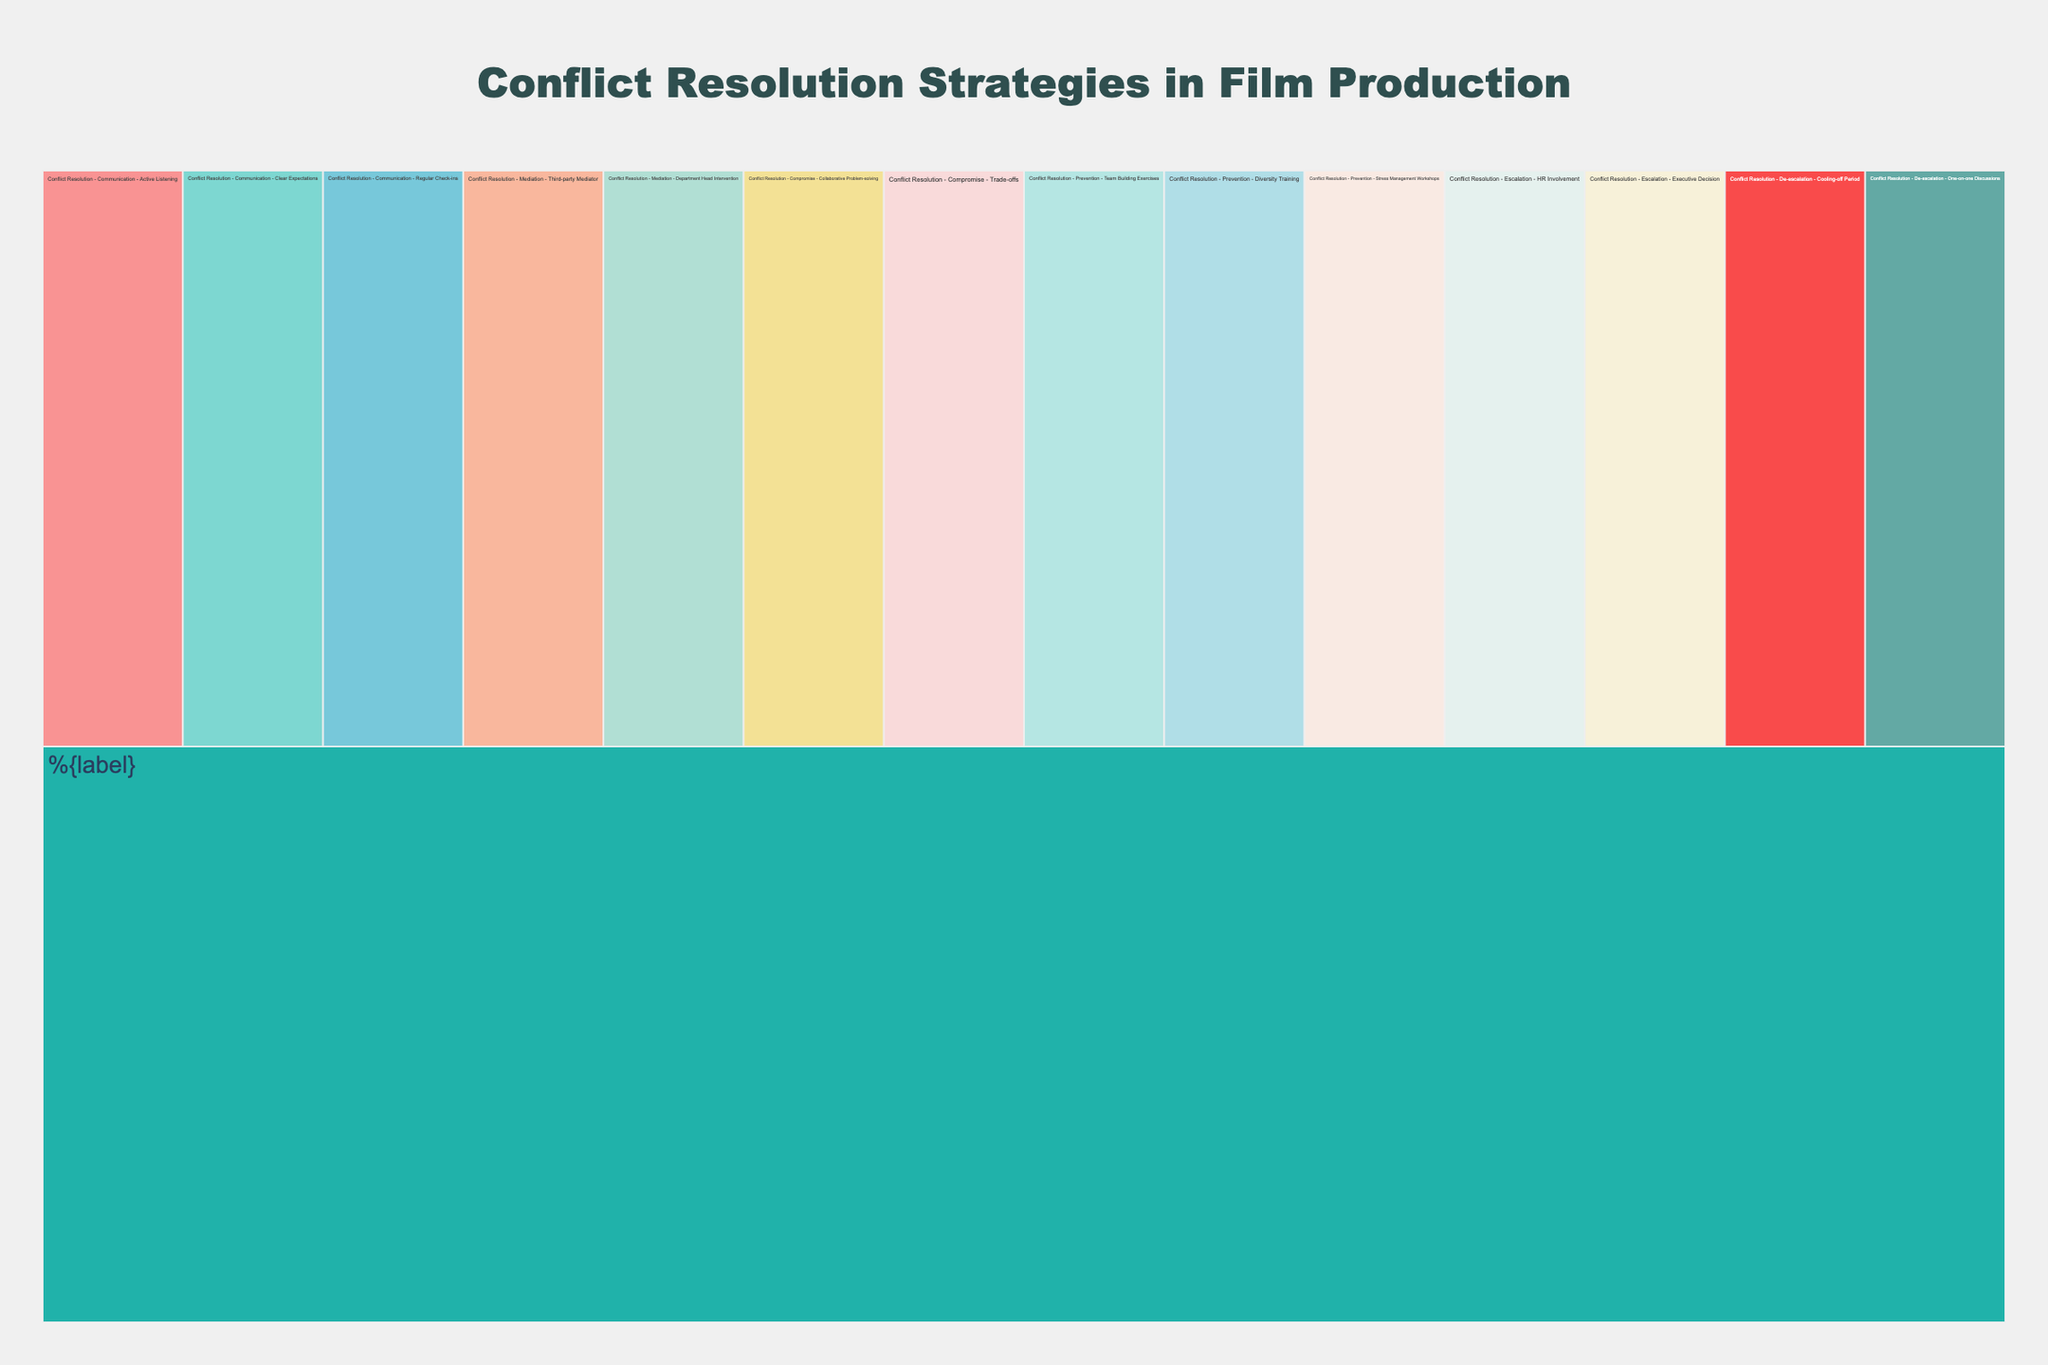What is the main category depicted in the icicle chart? The icicle chart is structured with a hierarchical organization. The root level represents the highest category, which is central to the chart's organization. On inspecting the root, we see that the main category is "Conflict Resolution".
Answer: Conflict Resolution How many subcategories are there under the main category? By counting the distinct branches that stem directly from the root category "Conflict Resolution," we identify six subcategories: Communication, Mediation, Compromise, Prevention, Escalation, and De-escalation.
Answer: 6 What are the strategies listed under the "Communication" subcategory? To find the strategies under a particular subcategory, look at the branches stemming from that subcategory. For "Communication," the branches are Active Listening, Clear Expectations, and Regular Check-ins.
Answer: Active Listening, Clear Expectations, Regular Check-ins Which subcategory has the least number of strategies? By comparing the number of strategies associated with each subcategory, we observe that "Escalation" and "De-escalation" each have 2 strategies, while the others have more.
Answer: Escalation, De-escalation How many strategies are listed in total across all subcategories? To find the total number of strategies, count the individual strategies from each subcategory. There are 3 (Communication) + 2 (Mediation) + 2 (Compromise) + 3 (Prevention) + 2 (Escalation) + 2 (De-escalation) strategies, summing to a total of 14.
Answer: 14 Which subcategory includes the "Team Building Exercises" strategy? By tracing the branch labeled "Team Building Exercises" upwards, its immediate parent subcategory is "Prevention".
Answer: Prevention How do the number of strategies in the "Mediation" subcategory compare with the "Compromise" subcategory? Both "Mediation" and "Compromise" have 2 strategies each. By counting the listed strategies under each, this comparison reveals they are equal.
Answer: They are equal Are there more strategies under "Prevention" or "Communication"? Counting the strategies under each subcategory shows that "Prevention" has 3 strategies, and "Communication" also has 3 strategies, making them equal in number.
Answer: They are equal Which subcategories have strategies involving third-party interventions? Both the "Mediation" and "Escalation" subcategories include strategies involving third-party interventions, as evidenced by the "Third-party Mediator" and "HR Involvement" strategies, respectively.
Answer: Mediation, Escalation Which subcategory includes more strategies: those preventing conflicts or those de-escalating conflicts? Comparing the number of strategies, "Prevention" has 3 strategies while "De-escalation" has 2 strategies. This implies there are more strategies aimed at preventing conflicts than de-escalating them.
Answer: Prevention 